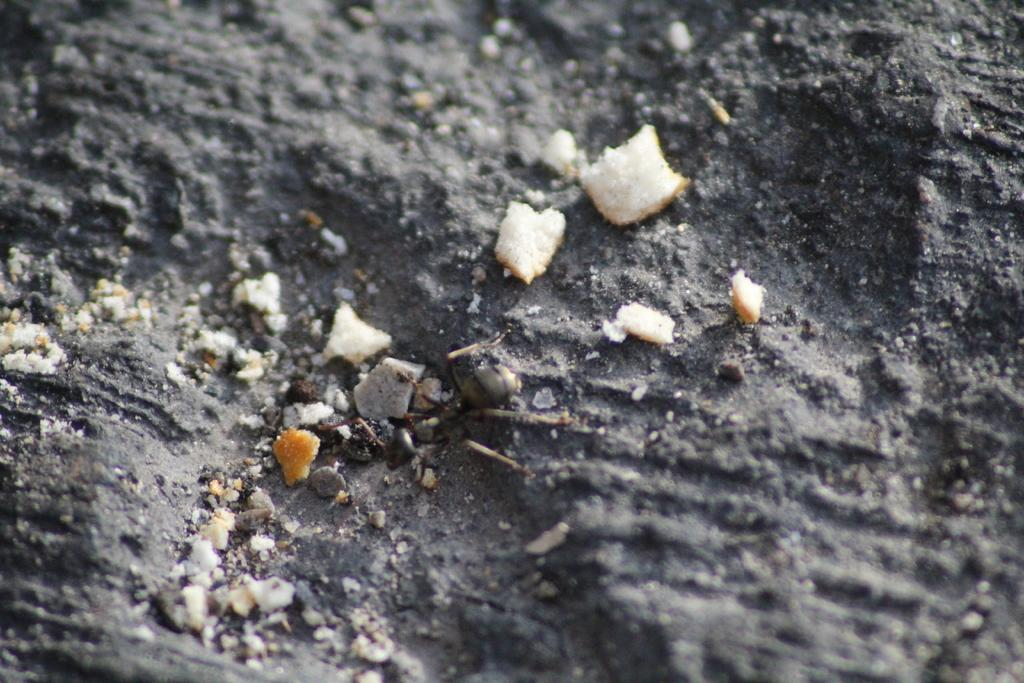What is on the ground in the image? There are bread slices on the ground in the image. What type of prison can be seen in the image? There is no prison present in the image; it features bread slices on the ground. What is the name of the club where the bread slices are located in the image? There is no club present in the image; it features bread slices on the ground. 